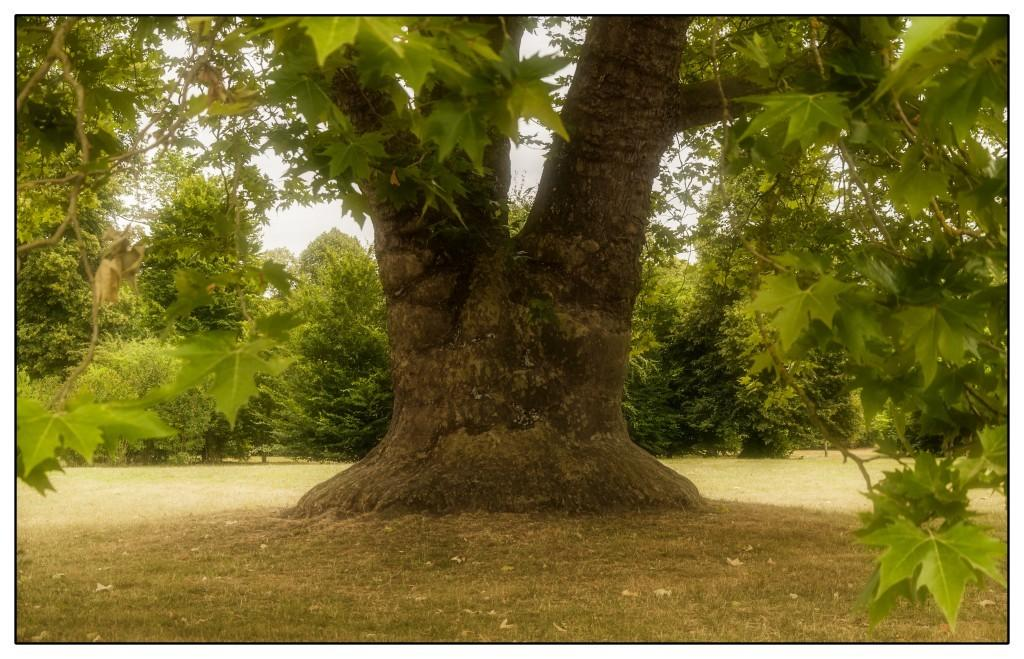What is the main subject in the center of the image? There is a tree in the center of the image. Are there any other trees visible in the image? Yes, there are additional trees visible in the image. What can be seen in the background of the image? The sky is visible in the background of the image. What type of metal is used to make the pies in the image? There are no pies present in the image, so it is not possible to determine the type of metal used to make them. 